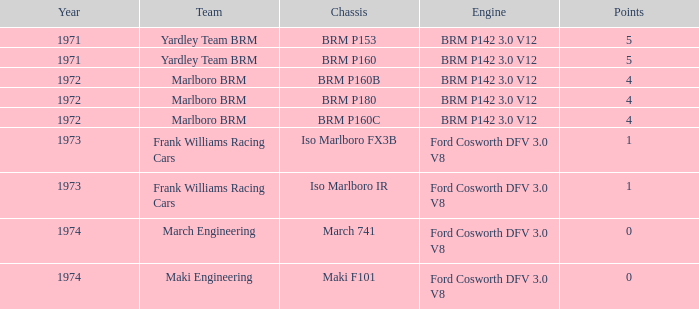What are the peak scores for the marlboro brm team using the brm p180 chassis? 4.0. I'm looking to parse the entire table for insights. Could you assist me with that? {'header': ['Year', 'Team', 'Chassis', 'Engine', 'Points'], 'rows': [['1971', 'Yardley Team BRM', 'BRM P153', 'BRM P142 3.0 V12', '5'], ['1971', 'Yardley Team BRM', 'BRM P160', 'BRM P142 3.0 V12', '5'], ['1972', 'Marlboro BRM', 'BRM P160B', 'BRM P142 3.0 V12', '4'], ['1972', 'Marlboro BRM', 'BRM P180', 'BRM P142 3.0 V12', '4'], ['1972', 'Marlboro BRM', 'BRM P160C', 'BRM P142 3.0 V12', '4'], ['1973', 'Frank Williams Racing Cars', 'Iso Marlboro FX3B', 'Ford Cosworth DFV 3.0 V8', '1'], ['1973', 'Frank Williams Racing Cars', 'Iso Marlboro IR', 'Ford Cosworth DFV 3.0 V8', '1'], ['1974', 'March Engineering', 'March 741', 'Ford Cosworth DFV 3.0 V8', '0'], ['1974', 'Maki Engineering', 'Maki F101', 'Ford Cosworth DFV 3.0 V8', '0']]} 